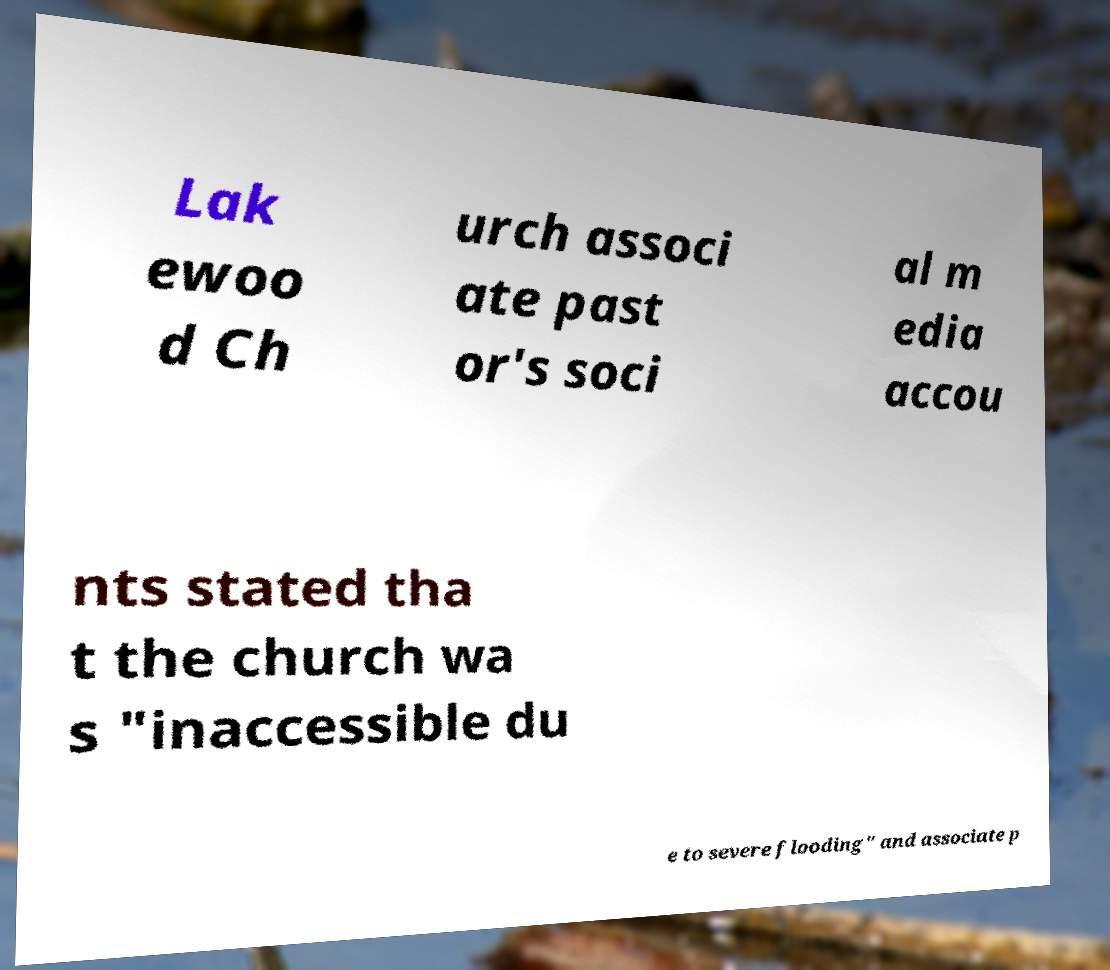For documentation purposes, I need the text within this image transcribed. Could you provide that? Lak ewoo d Ch urch associ ate past or's soci al m edia accou nts stated tha t the church wa s "inaccessible du e to severe flooding" and associate p 